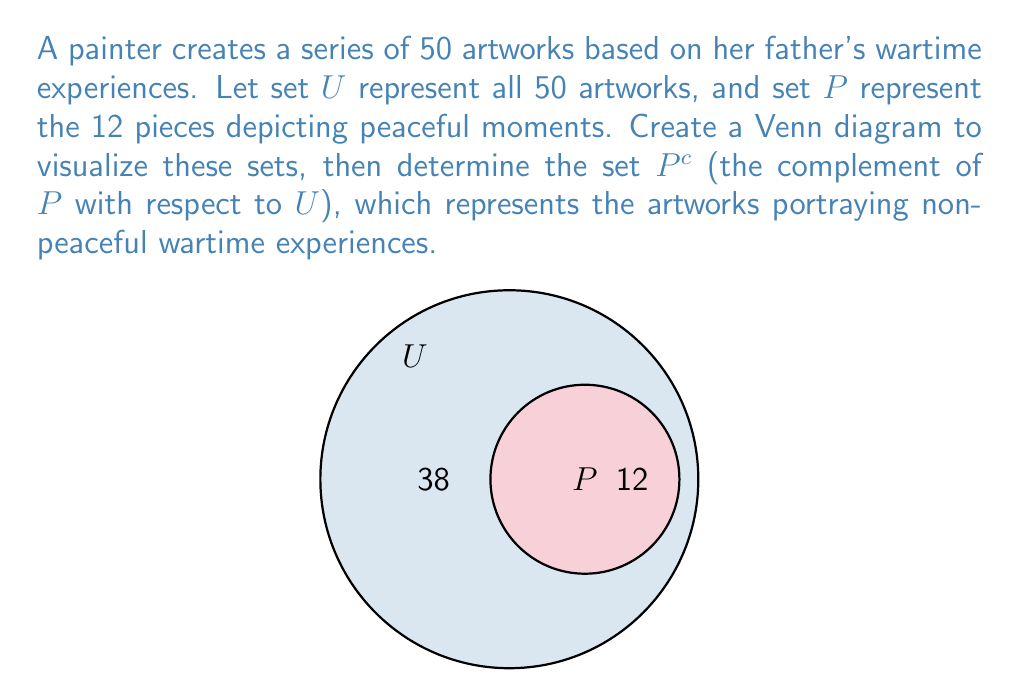Show me your answer to this math problem. To solve this problem, we'll follow these steps:

1) First, let's understand what the sets represent:
   $U$ = Universal set (all 50 artworks)
   $P$ = Set of artworks depicting peaceful moments (12 pieces)

2) The complement of set $P$, denoted as $P^c$, is the set of all elements in $U$ that are not in $P$. In other words, it's the set of artworks that do not depict peaceful moments.

3) To find $P^c$, we can use the formula:
   $P^c = U - P$

4) From the Venn diagram, we can see that:
   $|U| = 50$ (total number of artworks)
   $|P| = 12$ (number of peaceful artworks)

5) Therefore, the number of elements in $P^c$ is:
   $|P^c| = |U| - |P| = 50 - 12 = 38$

6) The set $P^c$ represents the 38 artworks that depict non-peaceful wartime experiences.
Answer: $P^c = \{x \in U : x \notin P\}$, where $|P^c| = 38$ 